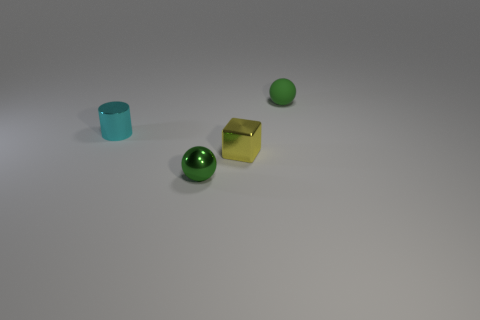What do you think could be the purpose of these objects? Based on their appearance, these objects could possibly be toys, decorative elements, or part of a learning activity for children involving shapes and colors. 